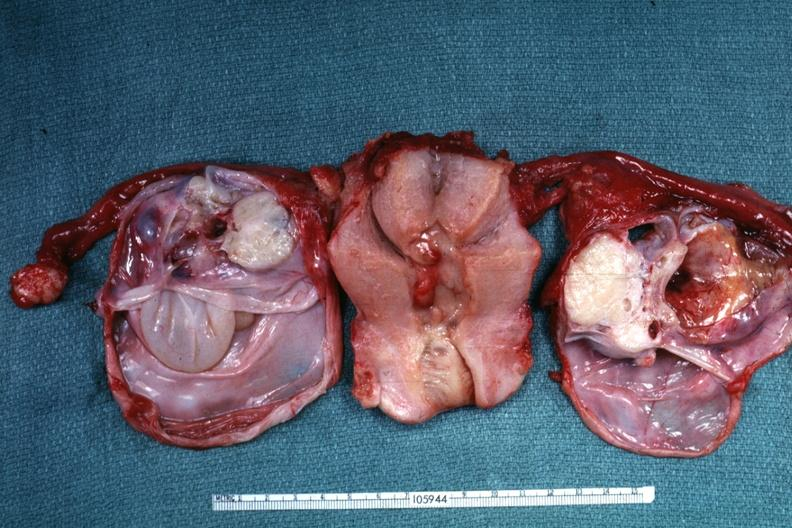does retroperitoneal liposarcoma show same as except ovaries have been cut to show multiloculated nature of tumor masses?
Answer the question using a single word or phrase. No 